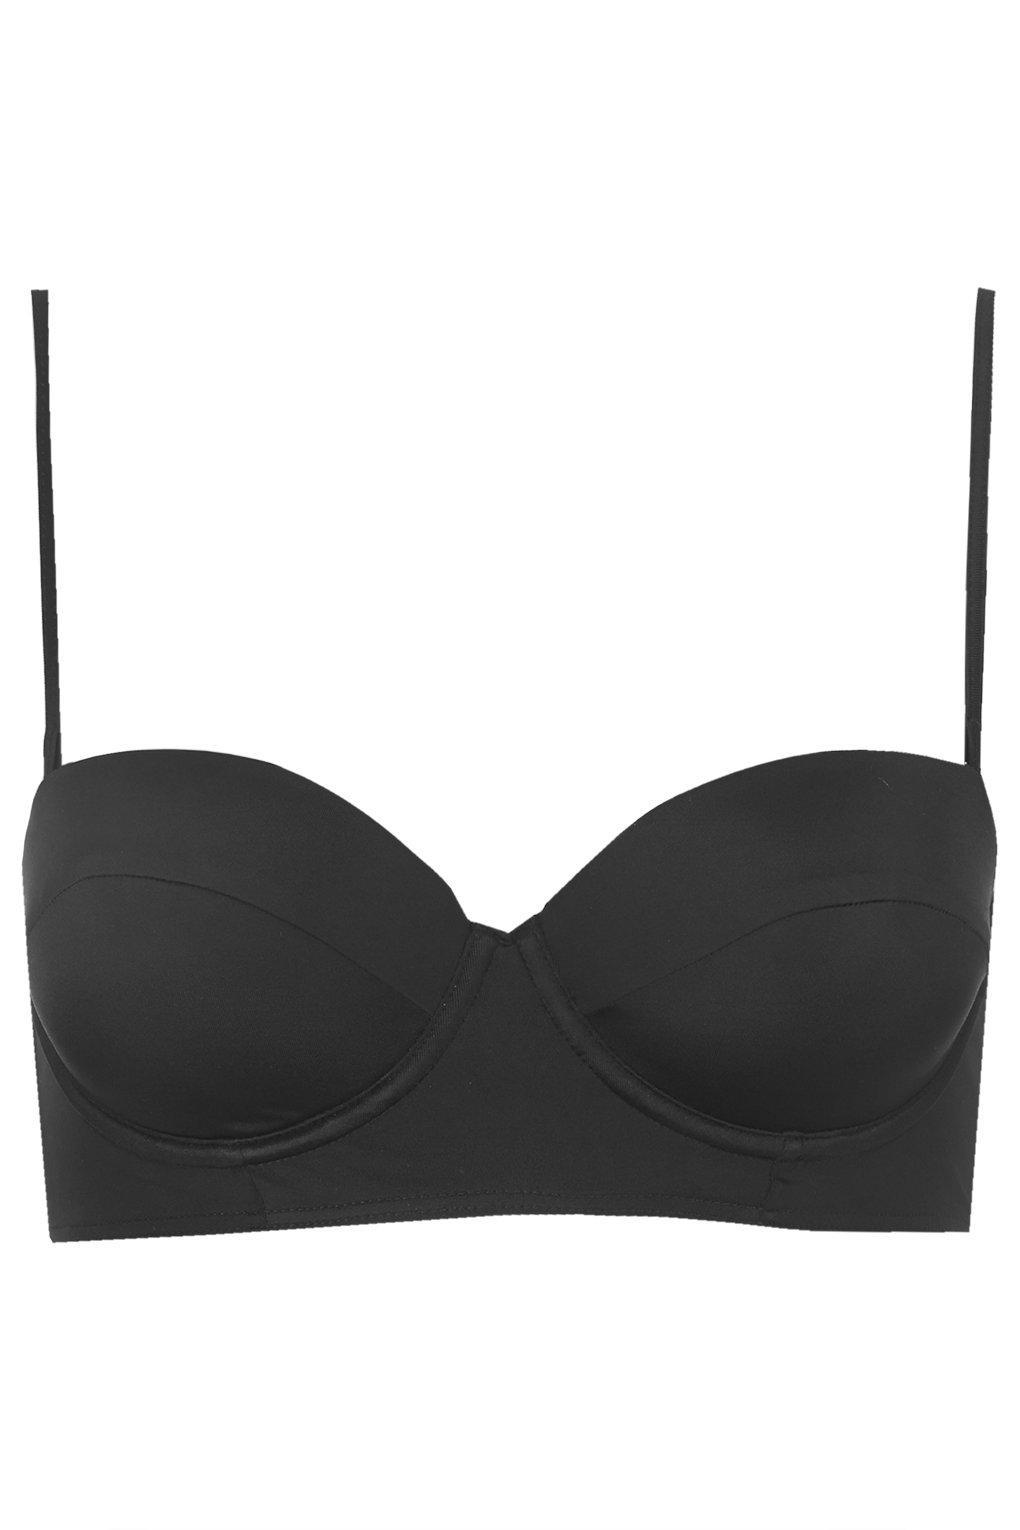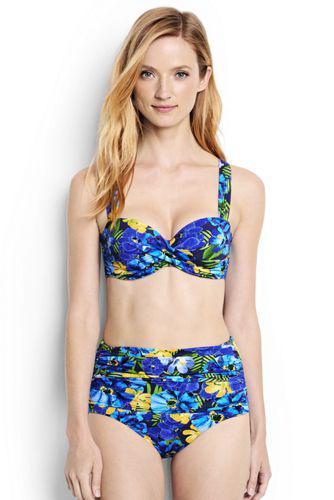The first image is the image on the left, the second image is the image on the right. Assess this claim about the two images: "At lease one of the swimsuits is pink.". Correct or not? Answer yes or no. No. 